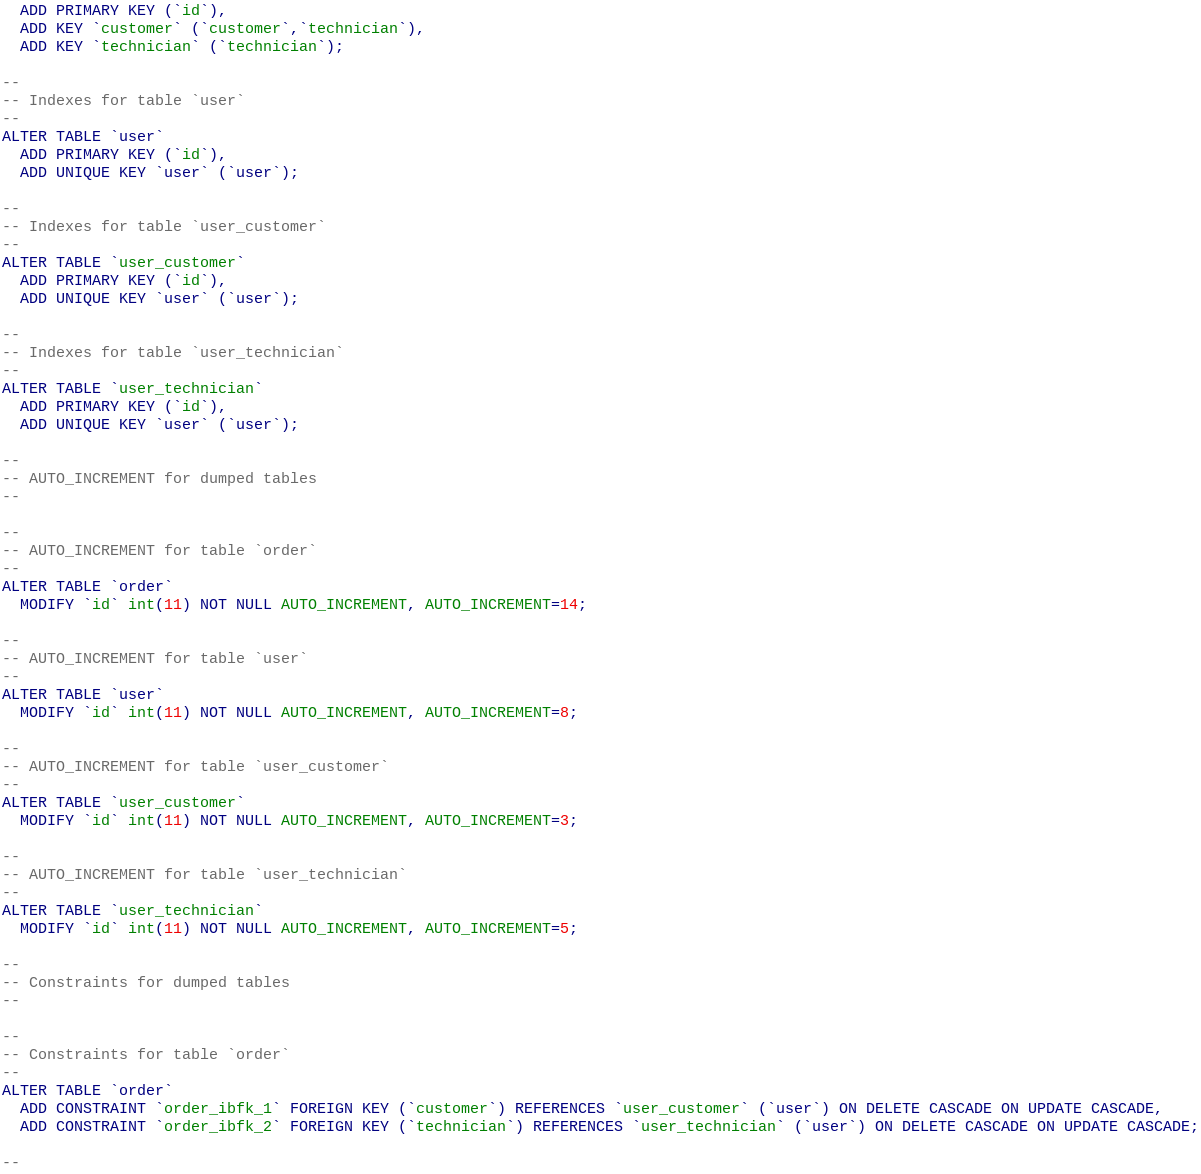<code> <loc_0><loc_0><loc_500><loc_500><_SQL_>  ADD PRIMARY KEY (`id`),
  ADD KEY `customer` (`customer`,`technician`),
  ADD KEY `technician` (`technician`);

--
-- Indexes for table `user`
--
ALTER TABLE `user`
  ADD PRIMARY KEY (`id`),
  ADD UNIQUE KEY `user` (`user`);

--
-- Indexes for table `user_customer`
--
ALTER TABLE `user_customer`
  ADD PRIMARY KEY (`id`),
  ADD UNIQUE KEY `user` (`user`);

--
-- Indexes for table `user_technician`
--
ALTER TABLE `user_technician`
  ADD PRIMARY KEY (`id`),
  ADD UNIQUE KEY `user` (`user`);

--
-- AUTO_INCREMENT for dumped tables
--

--
-- AUTO_INCREMENT for table `order`
--
ALTER TABLE `order`
  MODIFY `id` int(11) NOT NULL AUTO_INCREMENT, AUTO_INCREMENT=14;

--
-- AUTO_INCREMENT for table `user`
--
ALTER TABLE `user`
  MODIFY `id` int(11) NOT NULL AUTO_INCREMENT, AUTO_INCREMENT=8;

--
-- AUTO_INCREMENT for table `user_customer`
--
ALTER TABLE `user_customer`
  MODIFY `id` int(11) NOT NULL AUTO_INCREMENT, AUTO_INCREMENT=3;

--
-- AUTO_INCREMENT for table `user_technician`
--
ALTER TABLE `user_technician`
  MODIFY `id` int(11) NOT NULL AUTO_INCREMENT, AUTO_INCREMENT=5;

--
-- Constraints for dumped tables
--

--
-- Constraints for table `order`
--
ALTER TABLE `order`
  ADD CONSTRAINT `order_ibfk_1` FOREIGN KEY (`customer`) REFERENCES `user_customer` (`user`) ON DELETE CASCADE ON UPDATE CASCADE,
  ADD CONSTRAINT `order_ibfk_2` FOREIGN KEY (`technician`) REFERENCES `user_technician` (`user`) ON DELETE CASCADE ON UPDATE CASCADE;

--</code> 